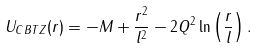Convert formula to latex. <formula><loc_0><loc_0><loc_500><loc_500>U _ { C B T Z } ( r ) = - M + \frac { r ^ { 2 } } { l ^ { 2 } } - 2 Q ^ { 2 } \ln \left ( \frac { r } { l } \right ) .</formula> 